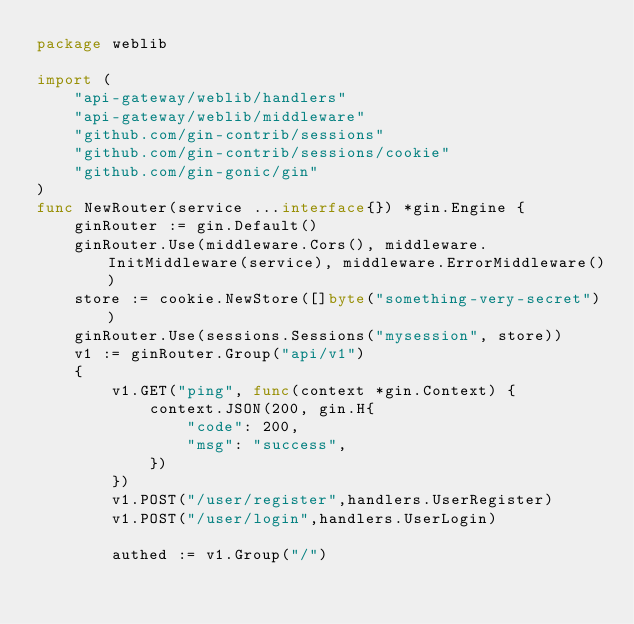<code> <loc_0><loc_0><loc_500><loc_500><_Go_>package weblib

import (
	"api-gateway/weblib/handlers"
	"api-gateway/weblib/middleware"
	"github.com/gin-contrib/sessions"
	"github.com/gin-contrib/sessions/cookie"
	"github.com/gin-gonic/gin"
)
func NewRouter(service ...interface{}) *gin.Engine {
	ginRouter := gin.Default()
	ginRouter.Use(middleware.Cors(), middleware.InitMiddleware(service), middleware.ErrorMiddleware())
	store := cookie.NewStore([]byte("something-very-secret"))
	ginRouter.Use(sessions.Sessions("mysession", store))
	v1 := ginRouter.Group("api/v1")
	{
		v1.GET("ping", func(context *gin.Context) {
			context.JSON(200, gin.H{
				"code": 200,
				"msg": "success",
			})
		})
		v1.POST("/user/register",handlers.UserRegister)
		v1.POST("/user/login",handlers.UserLogin)

		authed := v1.Group("/")</code> 